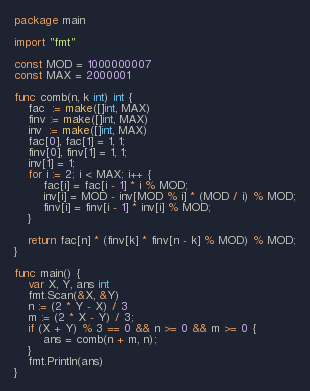Convert code to text. <code><loc_0><loc_0><loc_500><loc_500><_Go_>package main

import "fmt"

const MOD = 1000000007
const MAX = 2000001

func comb(n, k int) int {
	fac  := make([]int, MAX)
	finv := make([]int, MAX)
	inv  := make([]int, MAX)
	fac[0], fac[1] = 1, 1;
	finv[0], finv[1] = 1, 1;
	inv[1] = 1;
	for i := 2; i < MAX; i++ {
		fac[i] = fac[i - 1] * i % MOD;
		inv[i] = MOD - inv[MOD % i] * (MOD / i) % MOD;
		finv[i] = finv[i - 1] * inv[i] % MOD;
	}
	
	return fac[n] * (finv[k] * finv[n - k] % MOD) % MOD;
}

func main() {
	var X, Y, ans int
	fmt.Scan(&X, &Y)
	n := (2 * Y - X) / 3
	m := (2 * X - Y) / 3;
	if (X + Y) % 3 == 0 && n >= 0 && m >= 0 {
		ans = comb(n + m, n);
	}
	fmt.Println(ans)
}</code> 